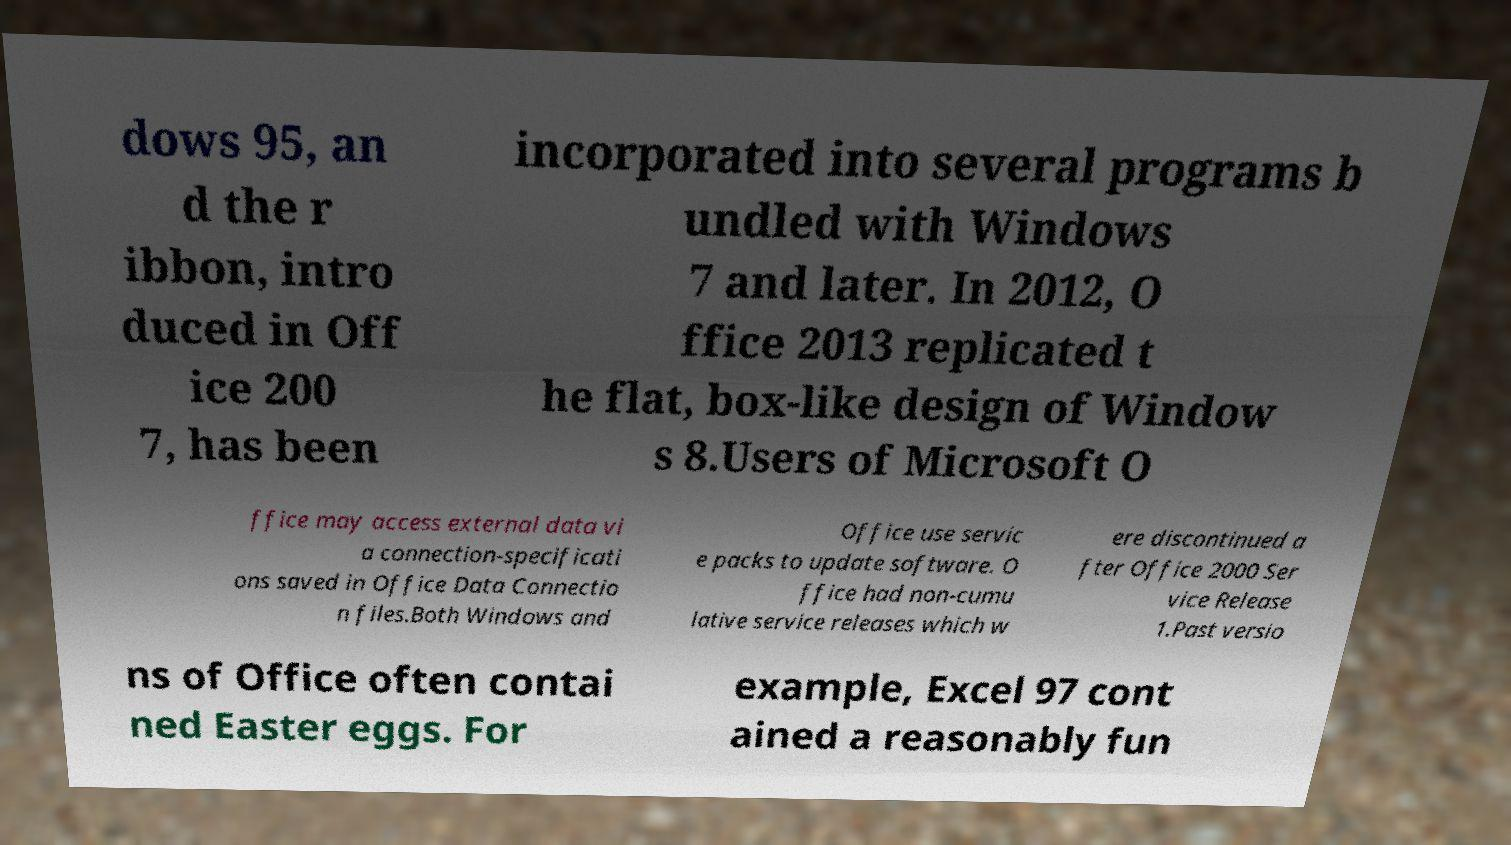I need the written content from this picture converted into text. Can you do that? dows 95, an d the r ibbon, intro duced in Off ice 200 7, has been incorporated into several programs b undled with Windows 7 and later. In 2012, O ffice 2013 replicated t he flat, box-like design of Window s 8.Users of Microsoft O ffice may access external data vi a connection-specificati ons saved in Office Data Connectio n files.Both Windows and Office use servic e packs to update software. O ffice had non-cumu lative service releases which w ere discontinued a fter Office 2000 Ser vice Release 1.Past versio ns of Office often contai ned Easter eggs. For example, Excel 97 cont ained a reasonably fun 